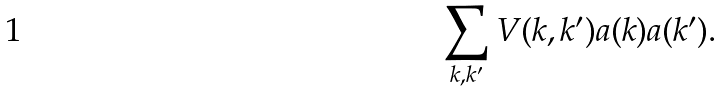Convert formula to latex. <formula><loc_0><loc_0><loc_500><loc_500>\sum _ { { k } , { k ^ { \prime } } } V ( { k } , { k ^ { \prime } } ) a ( { k } ) a ( { k ^ { \prime } } ) .</formula> 